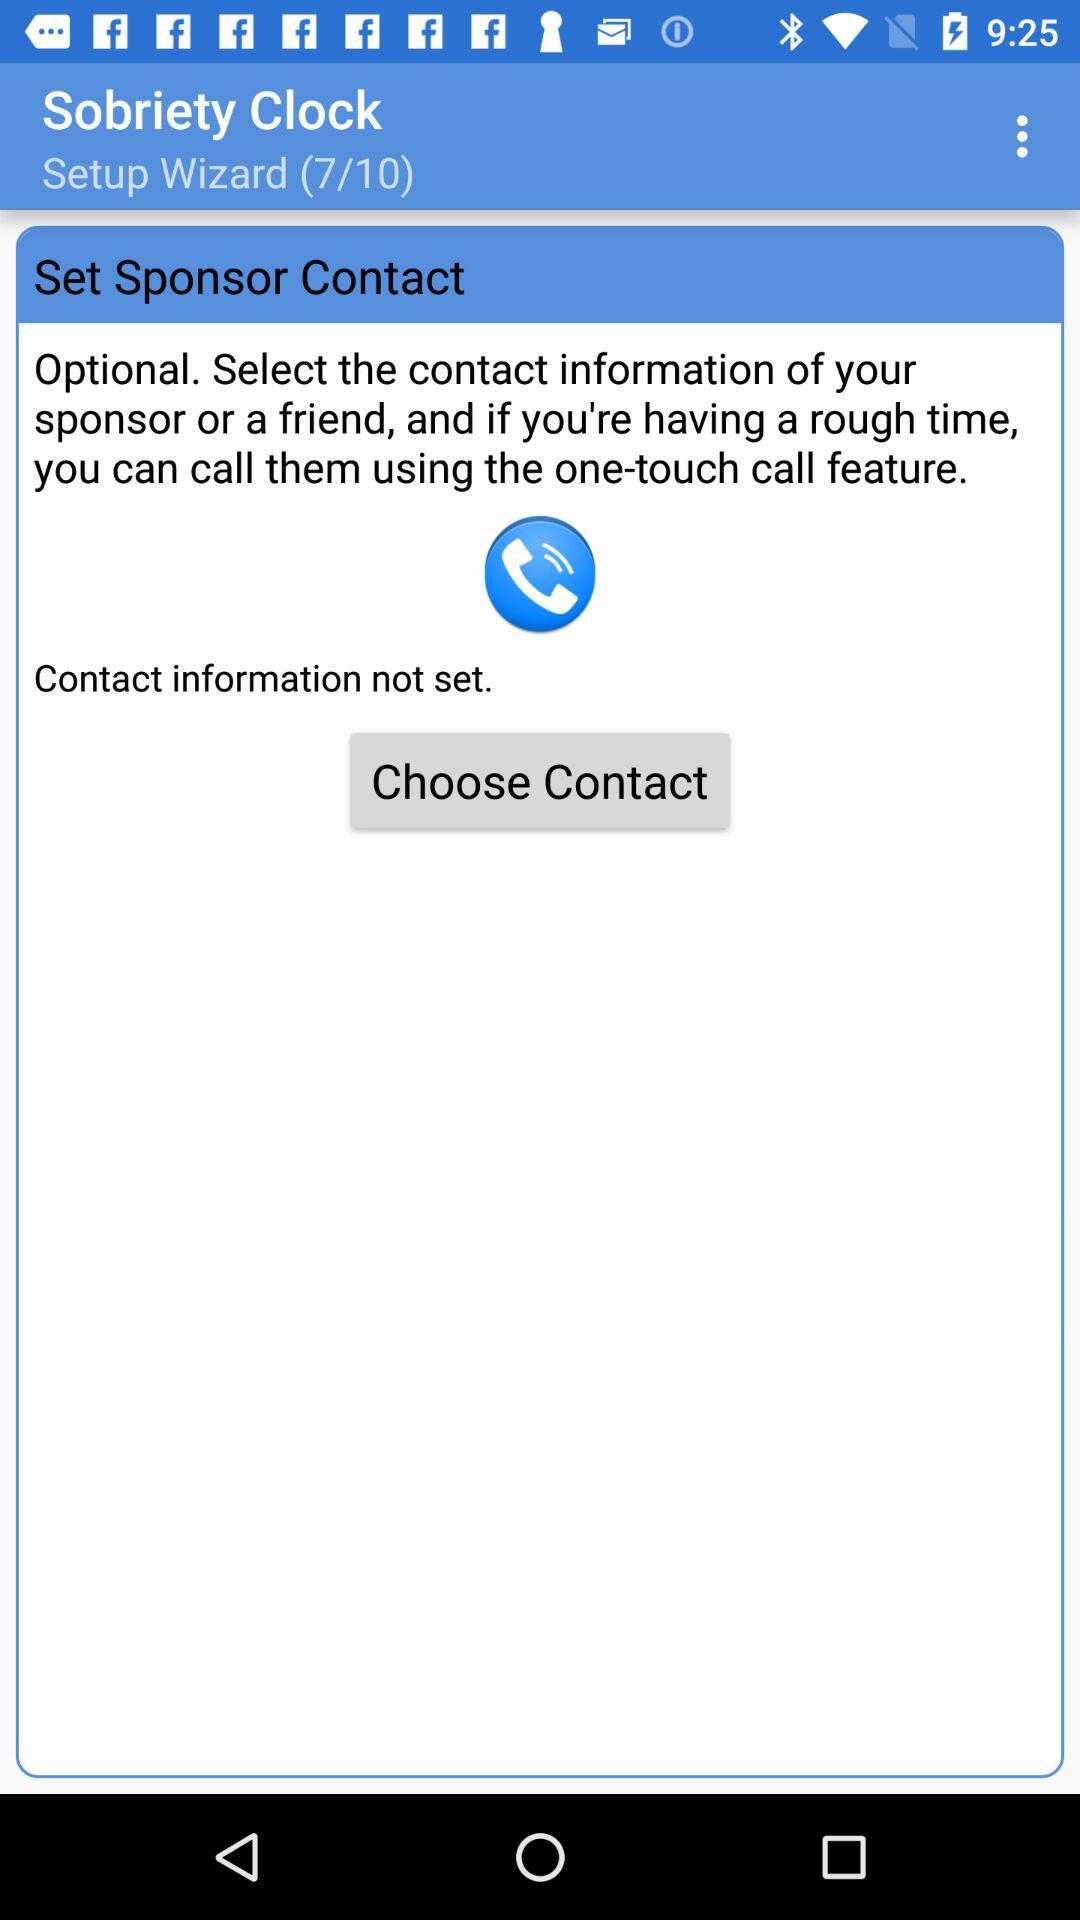Which step are we on? You are on step 7. 